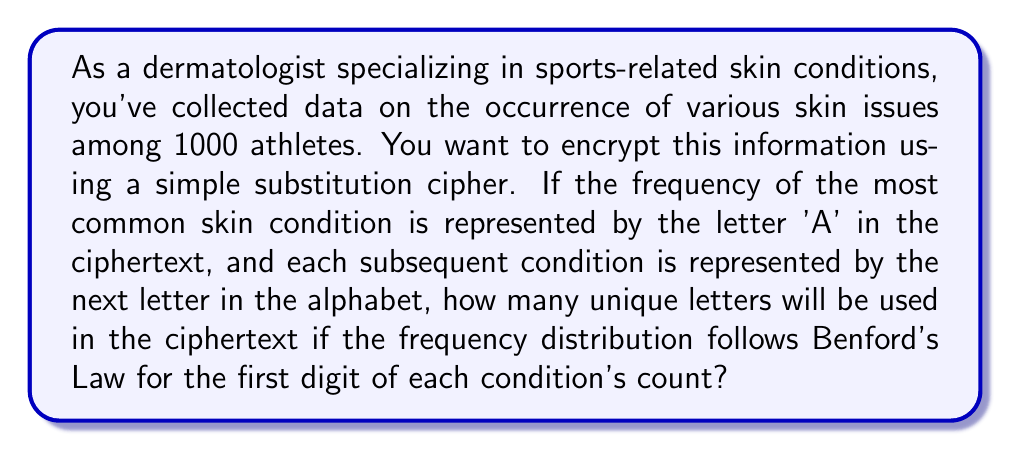Solve this math problem. Let's approach this step-by-step:

1) Benford's Law states that in many naturally occurring collections of numbers, the leading digit is distributed in a specific, non-uniform way. The probability of a number having a first digit of $d$ is given by:

   $$P(d) = \log_{10}(1 + \frac{1}{d})$$

2) We need to calculate this for digits 1 through 9:

   $P(1) = \log_{10}(2) \approx 0.301$
   $P(2) = \log_{10}(1.5) \approx 0.176$
   $P(3) = \log_{10}(1.333...) \approx 0.125$
   $P(4) = \log_{10}(1.25) \approx 0.097$
   $P(5) = \log_{10}(1.2) \approx 0.079$
   $P(6) = \log_{10}(1.167) \approx 0.067$
   $P(7) = \log_{10}(1.143) \approx 0.058$
   $P(8) = \log_{10}(1.125) \approx 0.051$
   $P(9) = \log_{10}(1.111...) \approx 0.046$

3) Given 1000 athletes, we can estimate the number of conditions starting with each digit:

   1: $301$ conditions
   2: $176$ conditions
   3: $125$ conditions
   4: $97$ conditions
   5: $79$ conditions
   6: $67$ conditions
   7: $58$ conditions
   8: $51$ conditions
   9: $46$ conditions

4) Each of these represents a unique skin condition in our data. Since we're assigning letters starting from 'A' for the most common condition, we'll use 9 unique letters (A through I).

Therefore, 9 unique letters will be used in the ciphertext.
Answer: 9 